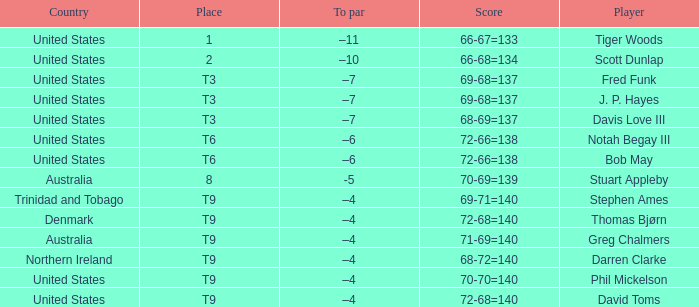What country is Darren Clarke from? Northern Ireland. 